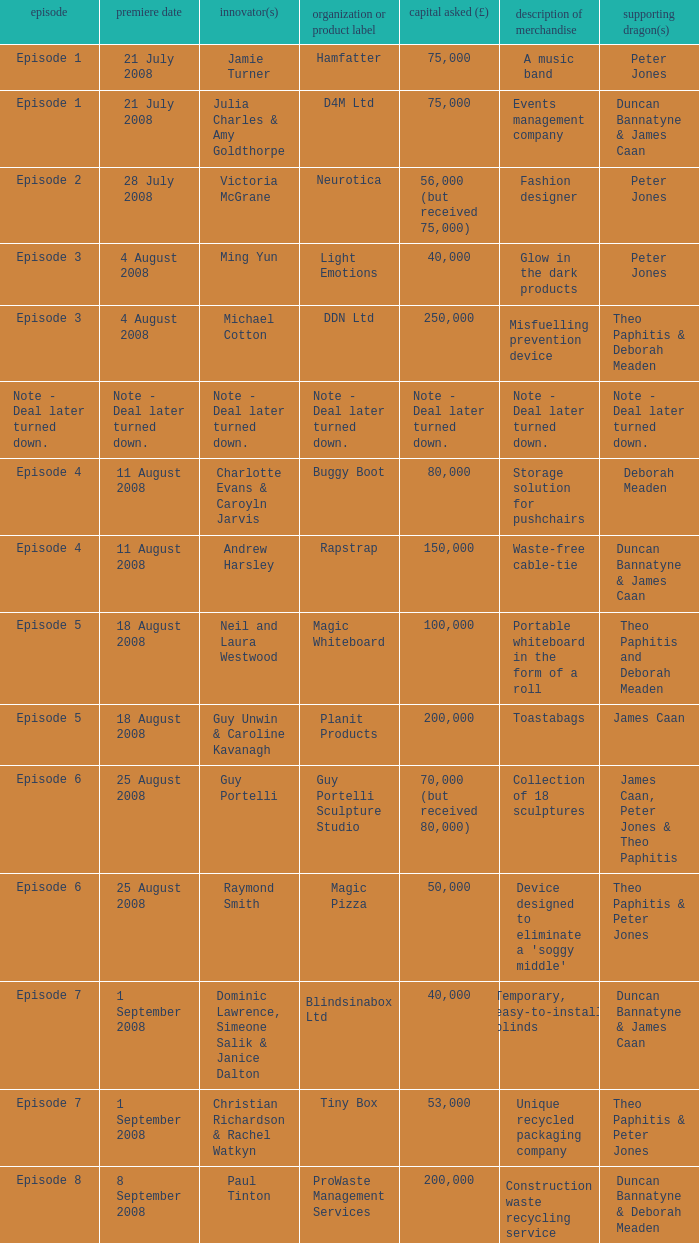How much money did the company Neurotica request? 56,000 (but received 75,000). 